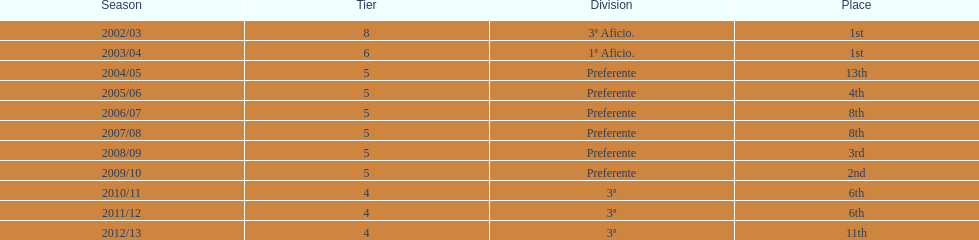In what year did the team achieve the same place as 2010/11? 2011/12. 